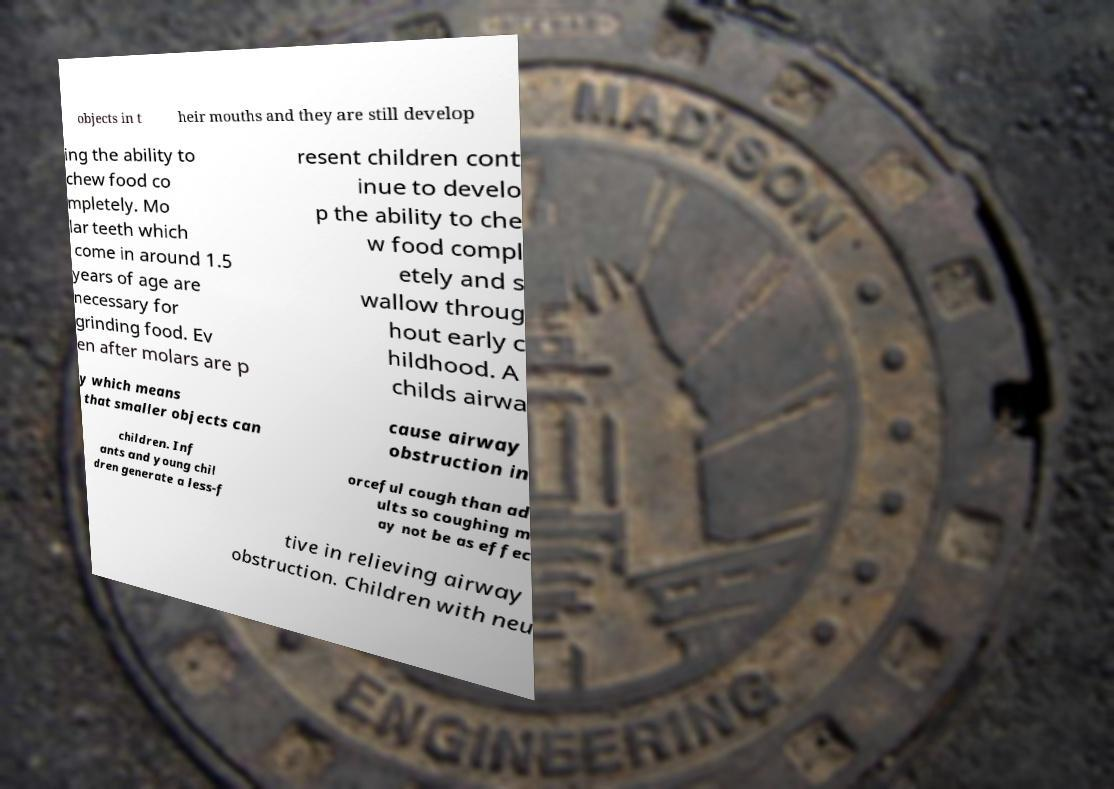Could you assist in decoding the text presented in this image and type it out clearly? objects in t heir mouths and they are still develop ing the ability to chew food co mpletely. Mo lar teeth which come in around 1.5 years of age are necessary for grinding food. Ev en after molars are p resent children cont inue to develo p the ability to che w food compl etely and s wallow throug hout early c hildhood. A childs airwa y which means that smaller objects can cause airway obstruction in children. Inf ants and young chil dren generate a less-f orceful cough than ad ults so coughing m ay not be as effec tive in relieving airway obstruction. Children with neu 